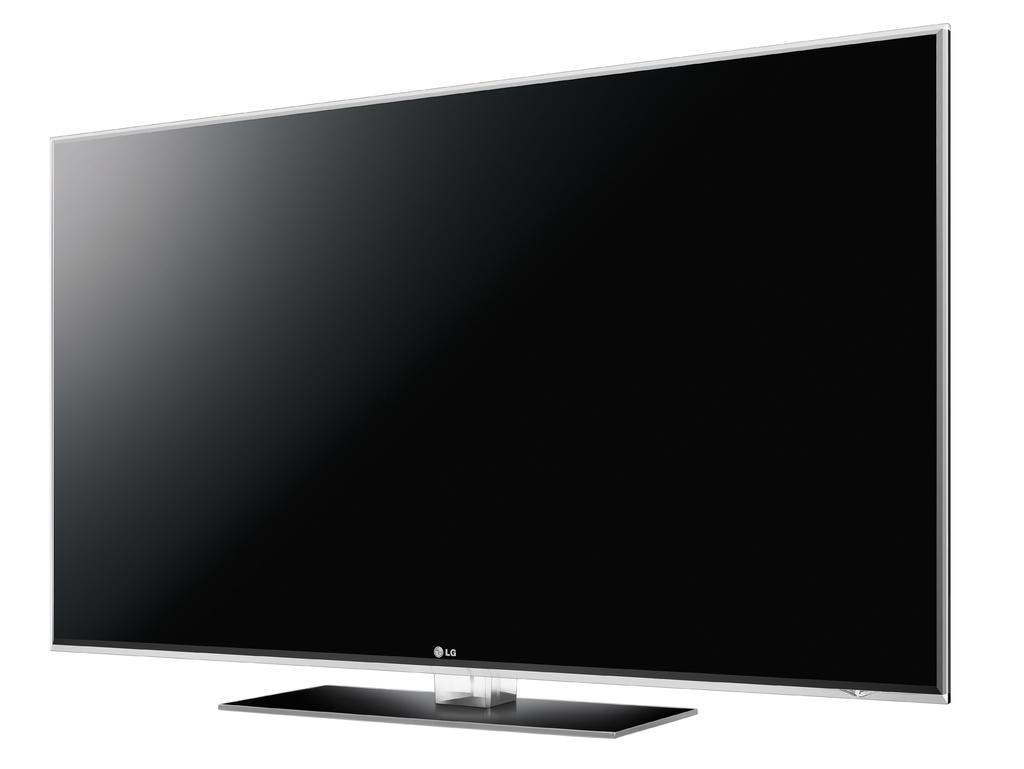Is this an lg tv?
Offer a terse response. Yes. What brand of tv is that?
Make the answer very short. Lg. 